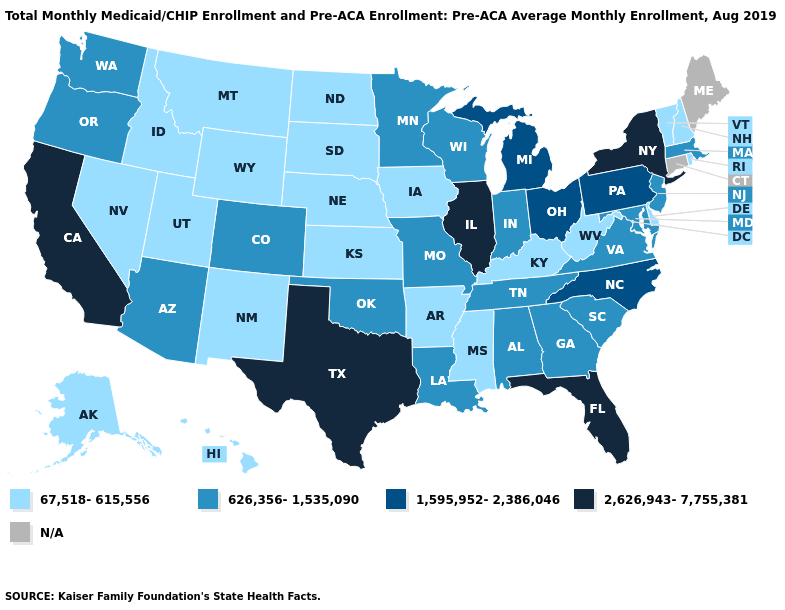What is the value of North Dakota?
Concise answer only. 67,518-615,556. What is the lowest value in the Northeast?
Answer briefly. 67,518-615,556. Does the map have missing data?
Be succinct. Yes. Which states hav the highest value in the MidWest?
Give a very brief answer. Illinois. What is the lowest value in states that border Missouri?
Quick response, please. 67,518-615,556. What is the value of Indiana?
Quick response, please. 626,356-1,535,090. Name the states that have a value in the range 1,595,952-2,386,046?
Answer briefly. Michigan, North Carolina, Ohio, Pennsylvania. What is the value of Utah?
Concise answer only. 67,518-615,556. Does Utah have the lowest value in the West?
Be succinct. Yes. What is the value of Arkansas?
Quick response, please. 67,518-615,556. Name the states that have a value in the range 626,356-1,535,090?
Short answer required. Alabama, Arizona, Colorado, Georgia, Indiana, Louisiana, Maryland, Massachusetts, Minnesota, Missouri, New Jersey, Oklahoma, Oregon, South Carolina, Tennessee, Virginia, Washington, Wisconsin. What is the value of Hawaii?
Keep it brief. 67,518-615,556. Among the states that border Ohio , which have the highest value?
Write a very short answer. Michigan, Pennsylvania. Does Arizona have the lowest value in the West?
Give a very brief answer. No. 